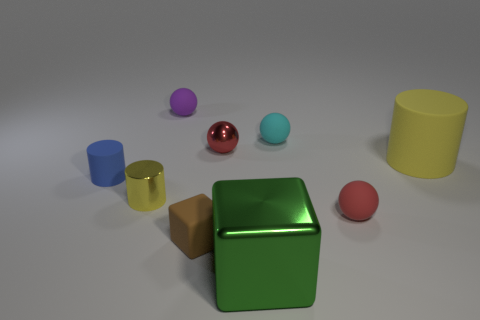What material is the small object left of the shiny object that is on the left side of the purple rubber ball made of?
Provide a short and direct response. Rubber. How many tiny brown rubber things are the same shape as the small purple object?
Keep it short and to the point. 0. What shape is the green metallic thing?
Your answer should be compact. Cube. Is the number of yellow metallic cylinders less than the number of big blue matte balls?
Your response must be concise. No. Is there any other thing that has the same size as the yellow rubber thing?
Your answer should be very brief. Yes. What material is the small blue object that is the same shape as the big yellow thing?
Ensure brevity in your answer.  Rubber. Are there more red shiny spheres than large brown metallic blocks?
Offer a terse response. Yes. What number of other objects are there of the same color as the tiny rubber cylinder?
Make the answer very short. 0. Is the material of the tiny blue cylinder the same as the yellow cylinder on the left side of the green thing?
Your answer should be very brief. No. There is a tiny red thing that is behind the cylinder in front of the blue rubber cylinder; how many blue cylinders are behind it?
Offer a terse response. 0. 